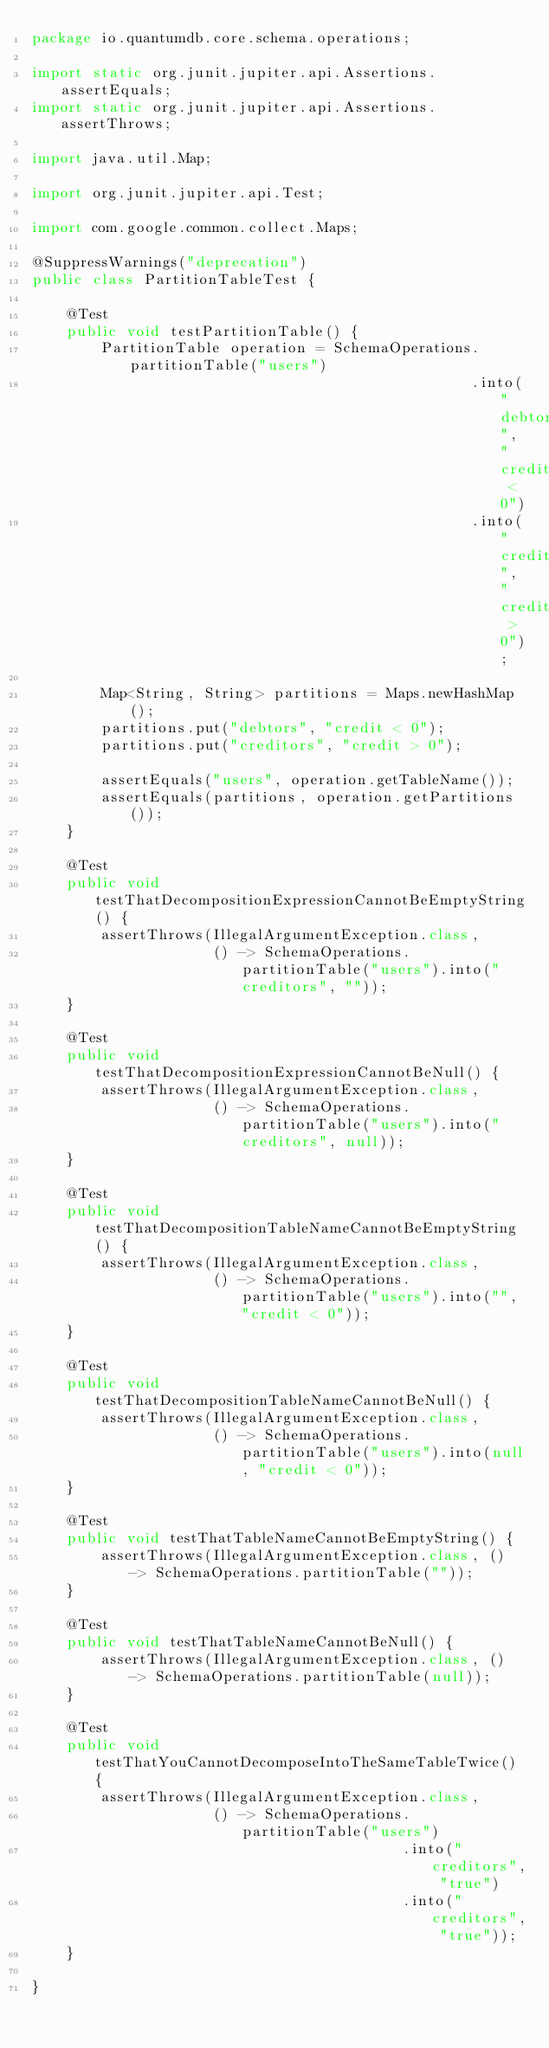Convert code to text. <code><loc_0><loc_0><loc_500><loc_500><_Java_>package io.quantumdb.core.schema.operations;

import static org.junit.jupiter.api.Assertions.assertEquals;
import static org.junit.jupiter.api.Assertions.assertThrows;

import java.util.Map;

import org.junit.jupiter.api.Test;

import com.google.common.collect.Maps;

@SuppressWarnings("deprecation")
public class PartitionTableTest {

    @Test
    public void testPartitionTable() {
        PartitionTable operation = SchemaOperations.partitionTable("users")
                                                   .into("debtors", "credit < 0")
                                                   .into("creditors", "credit > 0");

        Map<String, String> partitions = Maps.newHashMap();
        partitions.put("debtors", "credit < 0");
        partitions.put("creditors", "credit > 0");

        assertEquals("users", operation.getTableName());
        assertEquals(partitions, operation.getPartitions());
    }

    @Test
    public void testThatDecompositionExpressionCannotBeEmptyString() {
        assertThrows(IllegalArgumentException.class,
                     () -> SchemaOperations.partitionTable("users").into("creditors", ""));
    }

    @Test
    public void testThatDecompositionExpressionCannotBeNull() {
        assertThrows(IllegalArgumentException.class,
                     () -> SchemaOperations.partitionTable("users").into("creditors", null));
    }

    @Test
    public void testThatDecompositionTableNameCannotBeEmptyString() {
        assertThrows(IllegalArgumentException.class,
                     () -> SchemaOperations.partitionTable("users").into("", "credit < 0"));
    }

    @Test
    public void testThatDecompositionTableNameCannotBeNull() {
        assertThrows(IllegalArgumentException.class,
                     () -> SchemaOperations.partitionTable("users").into(null, "credit < 0"));
    }

    @Test
    public void testThatTableNameCannotBeEmptyString() {
        assertThrows(IllegalArgumentException.class, () -> SchemaOperations.partitionTable(""));
    }

    @Test
    public void testThatTableNameCannotBeNull() {
        assertThrows(IllegalArgumentException.class, () -> SchemaOperations.partitionTable(null));
    }

    @Test
    public void testThatYouCannotDecomposeIntoTheSameTableTwice() {
        assertThrows(IllegalArgumentException.class,
                     () -> SchemaOperations.partitionTable("users")
                                           .into("creditors", "true")
                                           .into("creditors", "true"));
    }

}
</code> 